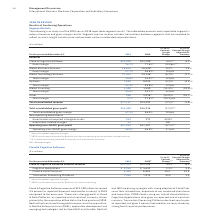According to International Business Machines's financial document, What caused the increase in Cloud & Cognitive Software revenue in 2019? There was strong growth in Cloud & Data Platforms, as reported and at constant currency, driven primarily by the acquisition of Red Hat in the third quarter of 2019. Red Hat had continued strong performance since the acquisition, in Red Hat Enterprise Linux (RHEL), application development and emerging technologies, led by OpenShift and Ansible.. The document states: "for currency) in 2019 compared to the prior year. There was strong growth in Cloud & Data Platforms, as reported and at constant currency, driven prim..." Also, What caused the increase in Cognitive Applications revenue in 2019? Based on the financial document, the answer is driven by double-digit growth as reported and adjusted for currency in Security, and growth in industry verticals such as IoT.. Also, What caused the increase in Cloud & Data Platforms revenue in 2019? Based on the financial document, the answer is Performance was driven by the addition of RHEL and OpenShift and the continued execution of the combined Red Hat and IBM hybrid strategy.. Also, can you calculate: What was the average Cloud & Cognitive Software external revenue in 2019 and 2018? To answer this question, I need to perform calculations using the financial data. The calculation is: (23,200 + 22,209) / 2, which equals 22704.5 (in millions). This is based on the information: "Cloud & Cognitive Software external revenue $23,200 $22,209 4.5% 6.2% ud & Cognitive Software external revenue $23,200 $22,209 4.5% 6.2%..." The key data points involved are: 22,209, 23,200. Also, can you calculate: What percentage of Cloud & Cognitive Software external revenue was Transaction Processing Platforms in 2019? Based on the calculation: 7,936 / 23,200, the result is 34.21 (percentage). This is based on the information: "Cloud & Cognitive Software external revenue $23,200 $22,209 4.5% 6.2% Transaction Processing Platforms 7,936 7,974 (0.5) 1.4..." The key data points involved are: 23,200, 7,936. Also, can you calculate: What is the average of Cloud & Data Platforms in 2019 and 2018? To answer this question, I need to perform calculations using the financial data. The calculation is: (9,499 + 8,603) / 2, which equals 9051 (in millions). This is based on the information: "Cloud & Data Platforms 9,499 8,603 10.4 12.3 Cloud & Data Platforms 9,499 8,603 10.4 12.3..." The key data points involved are: 8,603, 9,499. 